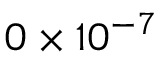Convert formula to latex. <formula><loc_0><loc_0><loc_500><loc_500>0 \times 1 0 ^ { - 7 }</formula> 